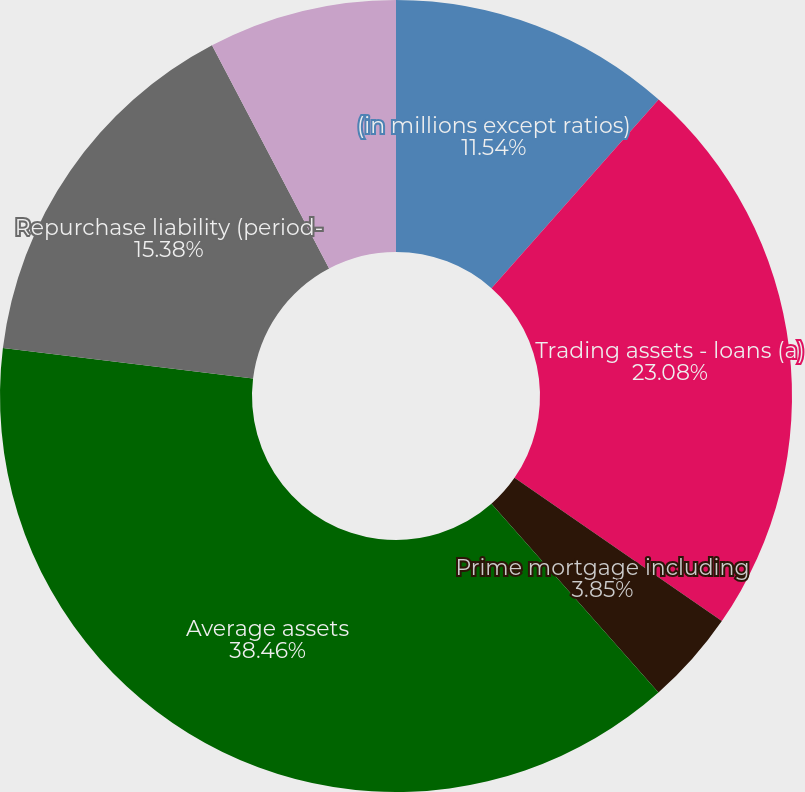Convert chart. <chart><loc_0><loc_0><loc_500><loc_500><pie_chart><fcel>(in millions except ratios)<fcel>Trading assets - loans (a)<fcel>Prime mortgage including<fcel>Average assets<fcel>Repurchase liability (period-<fcel>30+ day delinquency rate (c)<fcel>Nonperforming assets (d)(e)<nl><fcel>11.54%<fcel>23.08%<fcel>3.85%<fcel>38.46%<fcel>15.38%<fcel>0.0%<fcel>7.69%<nl></chart> 